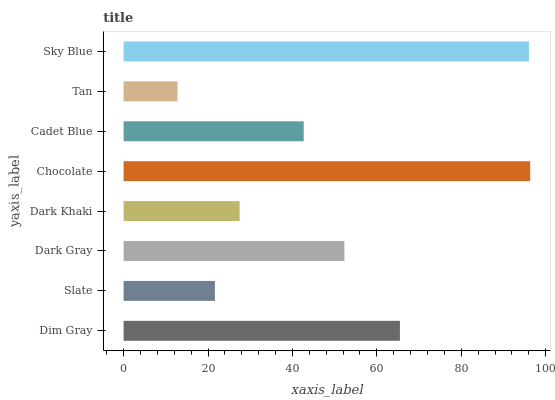Is Tan the minimum?
Answer yes or no. Yes. Is Chocolate the maximum?
Answer yes or no. Yes. Is Slate the minimum?
Answer yes or no. No. Is Slate the maximum?
Answer yes or no. No. Is Dim Gray greater than Slate?
Answer yes or no. Yes. Is Slate less than Dim Gray?
Answer yes or no. Yes. Is Slate greater than Dim Gray?
Answer yes or no. No. Is Dim Gray less than Slate?
Answer yes or no. No. Is Dark Gray the high median?
Answer yes or no. Yes. Is Cadet Blue the low median?
Answer yes or no. Yes. Is Slate the high median?
Answer yes or no. No. Is Dark Khaki the low median?
Answer yes or no. No. 